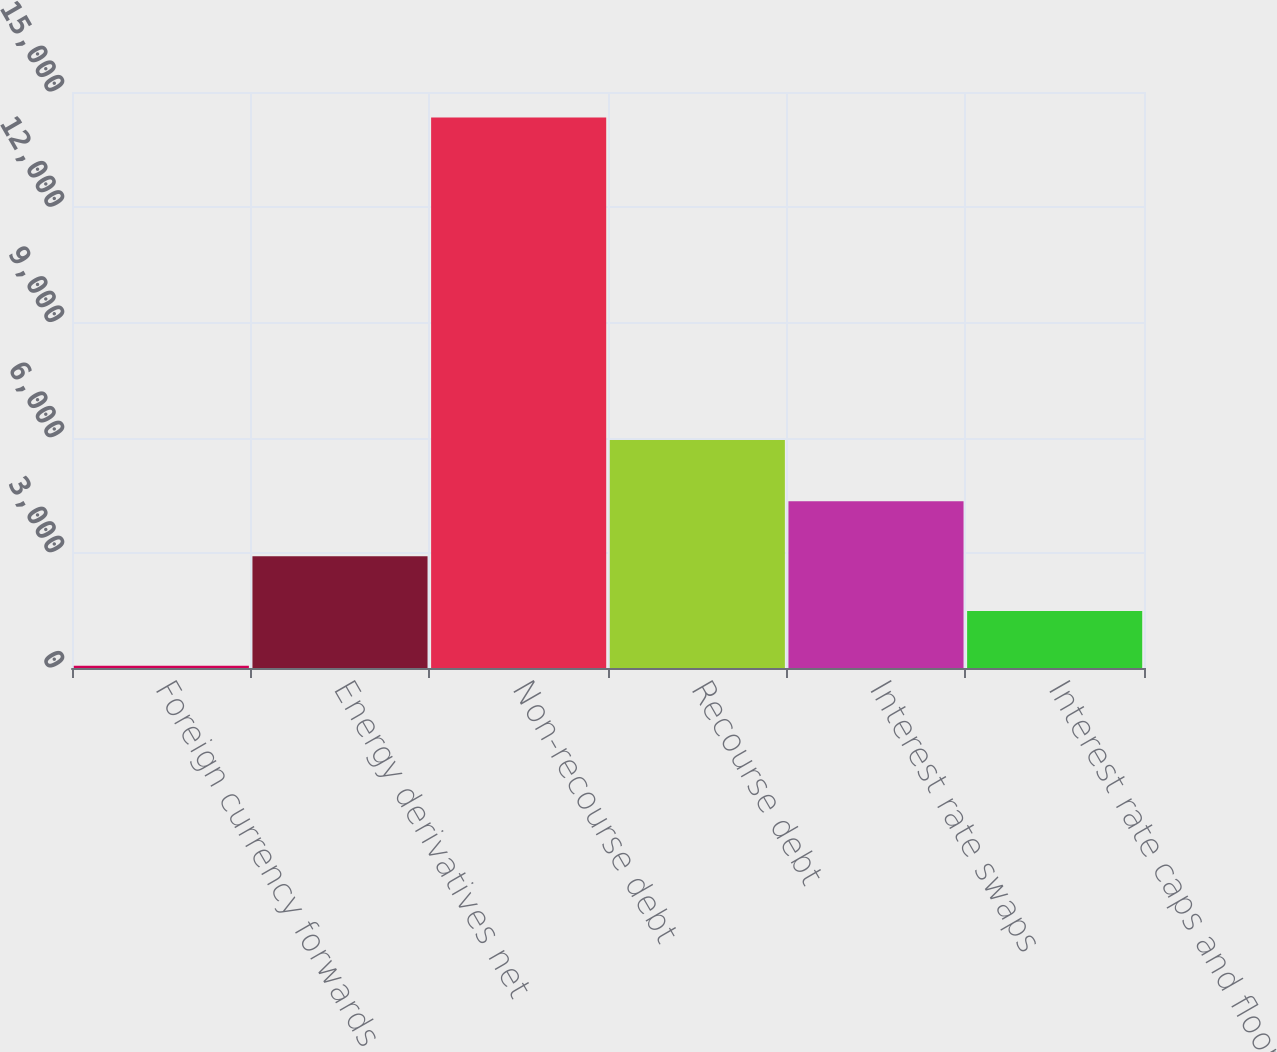Convert chart to OTSL. <chart><loc_0><loc_0><loc_500><loc_500><bar_chart><fcel>Foreign currency forwards and<fcel>Energy derivatives net<fcel>Non-recourse debt<fcel>Recourse debt<fcel>Interest rate swaps<fcel>Interest rate caps and floors<nl><fcel>56<fcel>2911.8<fcel>14335<fcel>5939<fcel>4339.7<fcel>1483.9<nl></chart> 